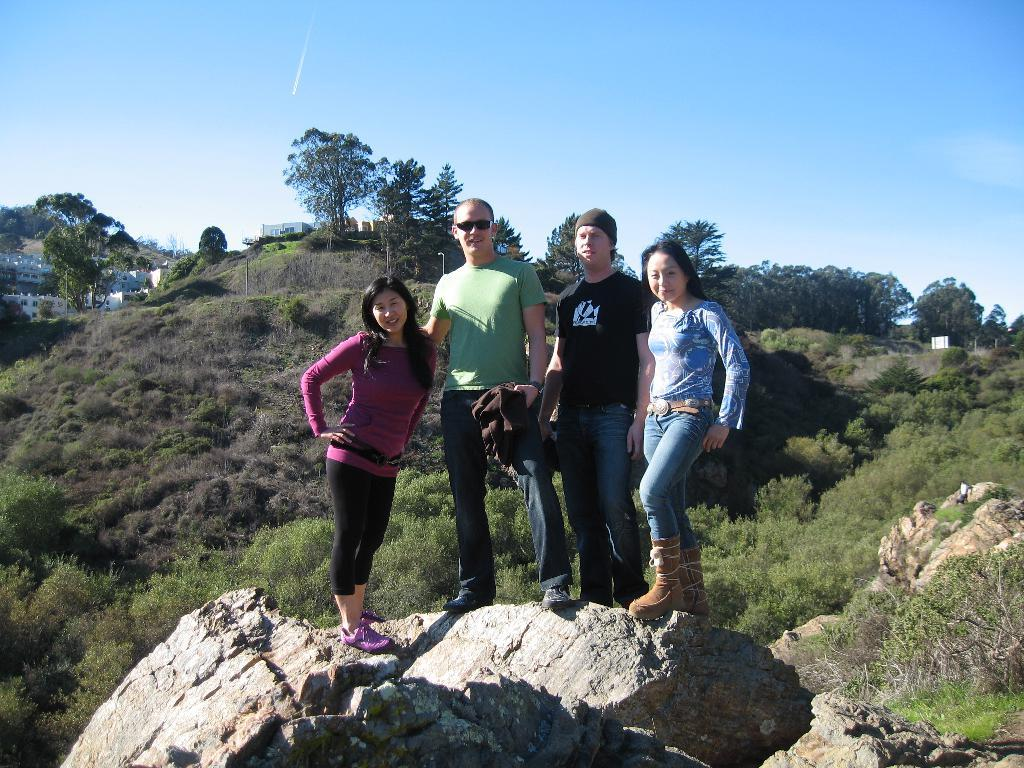How many people are in the image? There are four people in the image. What are the people doing in the image? The people are standing on a rock and posing for a picture. What can be seen in the background of the image? Buildings, trees, and mountains are visible in the background. What type of berry is being suggested by one of the people in the image? There is no berry or suggestion present in the image. Can you tell me which person is feeling angry in the image? There is no indication of anger or any specific emotion in the image. 